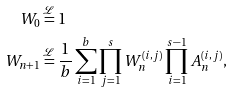<formula> <loc_0><loc_0><loc_500><loc_500>W _ { 0 } & \stackrel { \mathcal { L } } { = } 1 \\ W _ { n + 1 } & \stackrel { \mathcal { L } } { = } \frac { 1 } { b } \sum _ { i = 1 } ^ { b } \prod _ { j = 1 } ^ { s } W _ { n } ^ { ( i , j ) } \prod _ { i = 1 } ^ { s - 1 } A ^ { ( i , j ) } _ { n } ,</formula> 